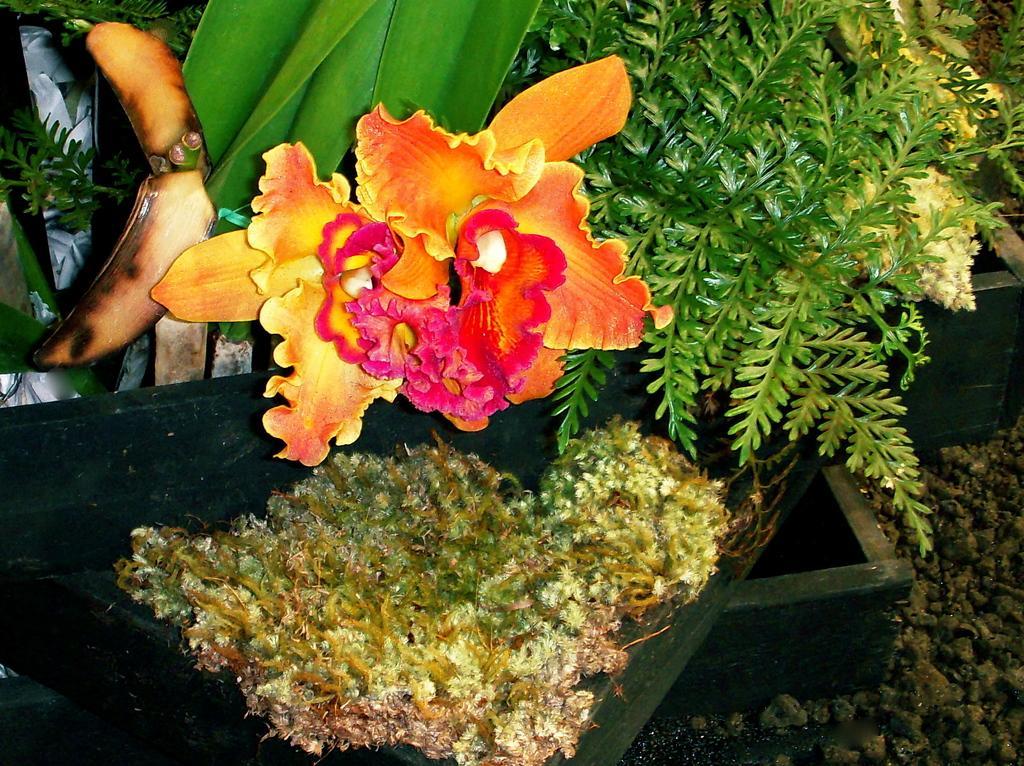Describe this image in one or two sentences. In this image, we can see some plants, a flower and some objects. We can also see the ground with some objects. 